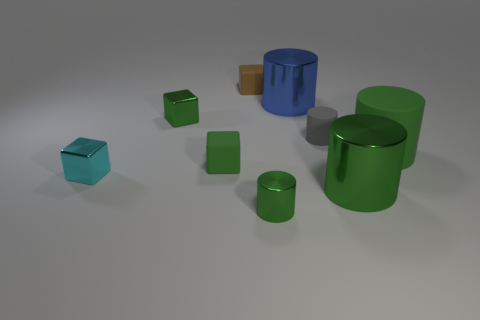Do the tiny green thing on the right side of the tiny brown block and the gray thing have the same material?
Offer a very short reply. No. Does the big rubber cylinder have the same color as the large cylinder in front of the large green matte cylinder?
Your answer should be compact. Yes. What is the shape of the green thing that is right of the big green metal cylinder to the right of the tiny green metallic cylinder?
Offer a terse response. Cylinder. There is a blue object; is it the same shape as the big thing that is in front of the tiny cyan metal block?
Provide a succinct answer. Yes. What number of green shiny things are to the right of the matte thing to the right of the small gray rubber object?
Provide a succinct answer. 0. What is the material of the cyan object that is the same shape as the brown rubber object?
Offer a very short reply. Metal. What number of blue things are either shiny cylinders or metal blocks?
Offer a very short reply. 1. Is there any other thing that has the same color as the tiny shiny cylinder?
Ensure brevity in your answer.  Yes. There is a small thing that is on the right side of the green metal cylinder that is on the left side of the blue cylinder; what is its color?
Offer a terse response. Gray. Are there fewer brown rubber things that are to the right of the tiny brown rubber cube than tiny green metal blocks that are on the left side of the blue metallic cylinder?
Make the answer very short. Yes. 